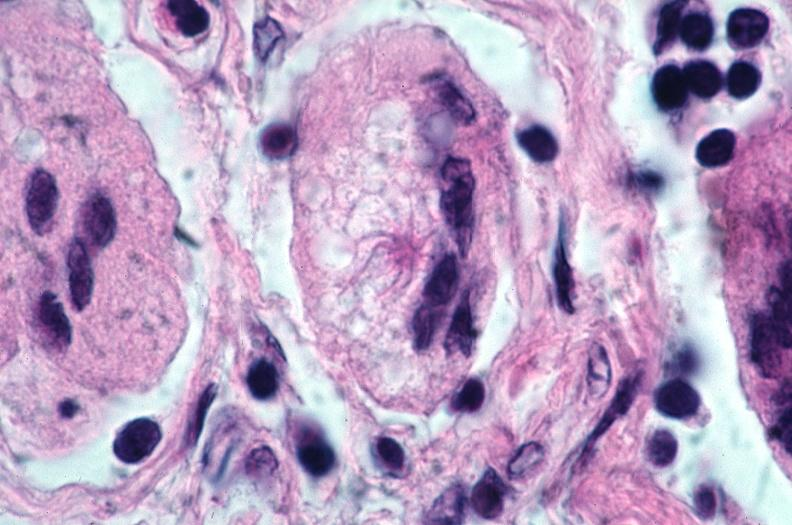does this image show lung, sarcoidosis, multinucleated giant cells with asteroid bodies?
Answer the question using a single word or phrase. Yes 